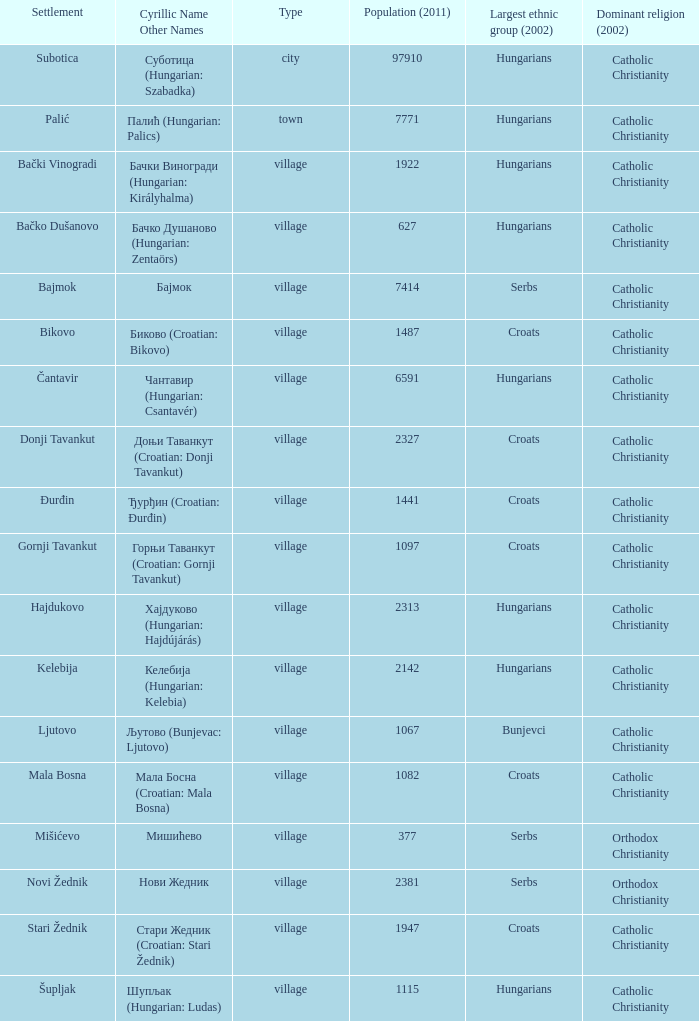What is the dominant religion in Gornji Tavankut? Catholic Christianity. 